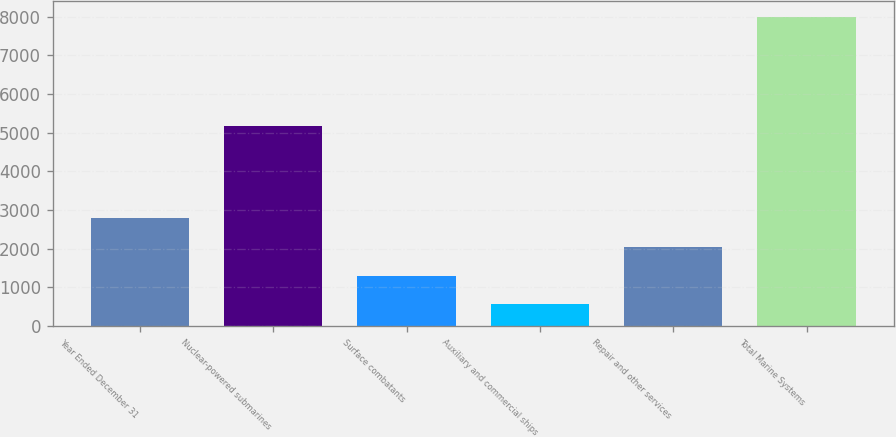Convert chart to OTSL. <chart><loc_0><loc_0><loc_500><loc_500><bar_chart><fcel>Year Ended December 31<fcel>Nuclear-powered submarines<fcel>Surface combatants<fcel>Auxiliary and commercial ships<fcel>Repair and other services<fcel>Total Marine Systems<nl><fcel>2796<fcel>5175<fcel>1308<fcel>564<fcel>2052<fcel>8004<nl></chart> 